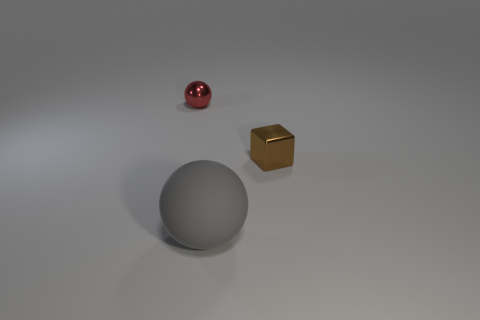How many other objects are there of the same size as the red thing?
Your answer should be compact. 1. Is there anything else that has the same material as the red thing?
Your answer should be compact. Yes. Is there a big blue sphere that has the same material as the tiny brown cube?
Offer a terse response. No. What is the material of the brown object that is the same size as the red metallic thing?
Offer a very short reply. Metal. How many other big purple objects have the same shape as the big rubber object?
Your answer should be compact. 0. There is a block that is made of the same material as the red sphere; what is its size?
Offer a very short reply. Small. There is a thing that is behind the gray thing and right of the small sphere; what is its material?
Your response must be concise. Metal. How many other matte balls are the same size as the gray sphere?
Provide a short and direct response. 0. What material is the other object that is the same shape as the tiny red shiny thing?
Keep it short and to the point. Rubber. How many objects are metal objects that are right of the matte sphere or objects that are on the left side of the small cube?
Your answer should be very brief. 3. 